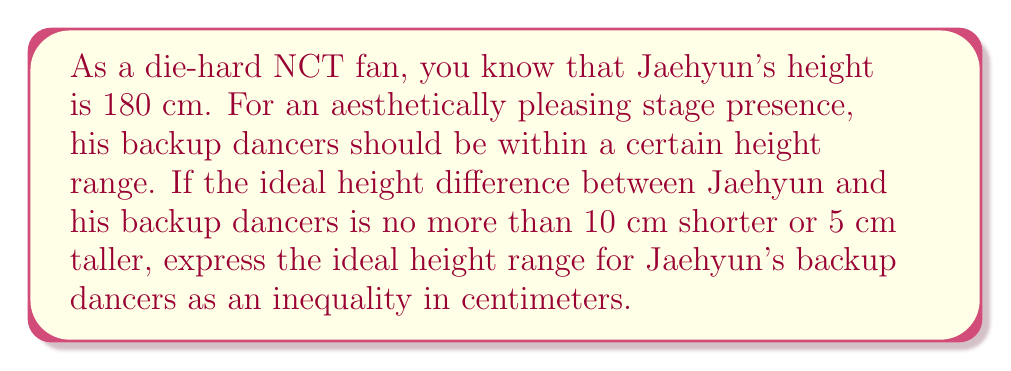Help me with this question. Let's approach this step-by-step:

1) Jaehyun's height is 180 cm.

2) The backup dancers should be:
   - No more than 10 cm shorter than Jaehyun
   - No more than 5 cm taller than Jaehyun

3) Let's define $x$ as the height of a backup dancer in centimeters.

4) For the lower bound:
   $x \geq 180 - 10$
   $x \geq 170$

5) For the upper bound:
   $x \leq 180 + 5$
   $x \leq 185$

6) Combining these inequalities:
   $170 \leq x \leq 185$

This can be written as a compound inequality:

$$170 \leq x \leq 185$$

where $x$ represents the height of a backup dancer in centimeters.
Answer: $170 \leq x \leq 185$, where $x$ is the height of a backup dancer in centimeters. 